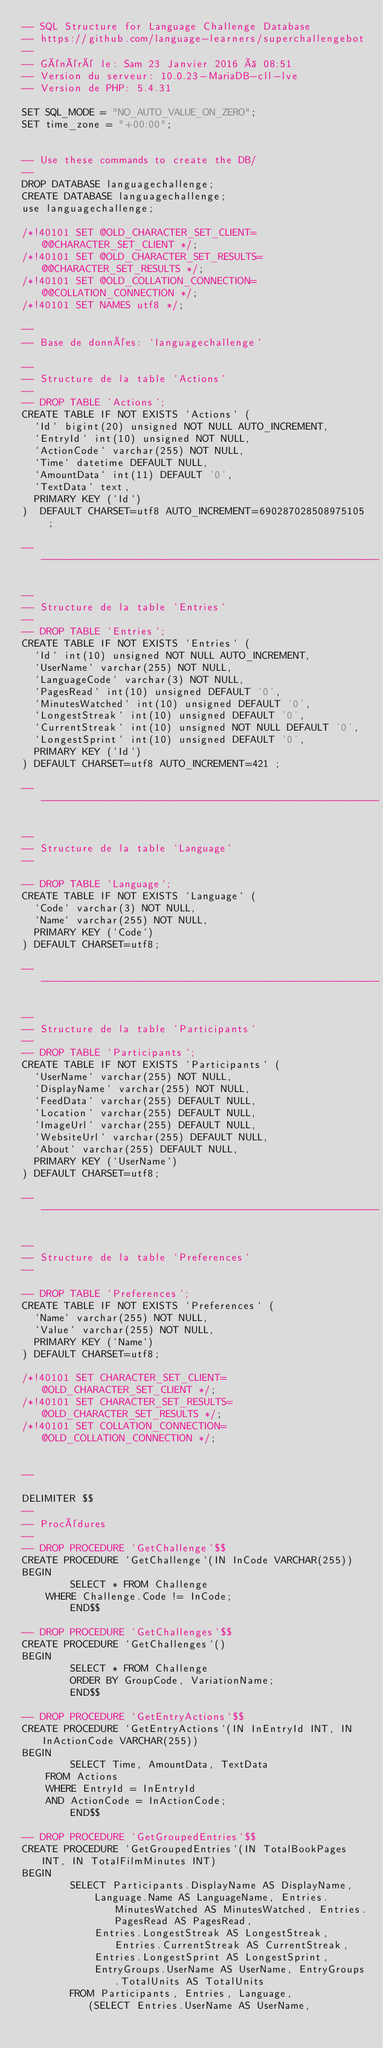Convert code to text. <code><loc_0><loc_0><loc_500><loc_500><_SQL_>-- SQL Structure for Language Challenge Database
-- https://github.com/language-learners/superchallengebot
--
-- Généré le: Sam 23 Janvier 2016 à 08:51
-- Version du serveur: 10.0.23-MariaDB-cll-lve
-- Version de PHP: 5.4.31

SET SQL_MODE = "NO_AUTO_VALUE_ON_ZERO";
SET time_zone = "+00:00";


-- Use these commands to create the DB/
-- 
DROP DATABASE languagechallenge;
CREATE DATABASE languagechallenge;
use languagechallenge;

/*!40101 SET @OLD_CHARACTER_SET_CLIENT=@@CHARACTER_SET_CLIENT */;
/*!40101 SET @OLD_CHARACTER_SET_RESULTS=@@CHARACTER_SET_RESULTS */;
/*!40101 SET @OLD_COLLATION_CONNECTION=@@COLLATION_CONNECTION */;
/*!40101 SET NAMES utf8 */;

--
-- Base de données: `languagechallenge`

--
-- Structure de la table `Actions`
--
-- DROP TABLE `Actions`;
CREATE TABLE IF NOT EXISTS `Actions` (
  `Id` bigint(20) unsigned NOT NULL AUTO_INCREMENT,
  `EntryId` int(10) unsigned NOT NULL,
  `ActionCode` varchar(255) NOT NULL,
  `Time` datetime DEFAULT NULL,
  `AmountData` int(11) DEFAULT '0',
  `TextData` text,
  PRIMARY KEY (`Id`)
)  DEFAULT CHARSET=utf8 AUTO_INCREMENT=690287028508975105 ;

-- --------------------------------------------------------

--
-- Structure de la table `Entries`
--
-- DROP TABLE `Entries`;
CREATE TABLE IF NOT EXISTS `Entries` (
  `Id` int(10) unsigned NOT NULL AUTO_INCREMENT,
  `UserName` varchar(255) NOT NULL,
  `LanguageCode` varchar(3) NOT NULL,
  `PagesRead` int(10) unsigned DEFAULT '0',
  `MinutesWatched` int(10) unsigned DEFAULT '0',
  `LongestStreak` int(10) unsigned DEFAULT '0',
  `CurrentStreak` int(10) unsigned NOT NULL DEFAULT '0',
  `LongestSprint` int(10) unsigned DEFAULT '0',
  PRIMARY KEY (`Id`)
) DEFAULT CHARSET=utf8 AUTO_INCREMENT=421 ;

-- --------------------------------------------------------

--
-- Structure de la table `Language`
--

-- DROP TABLE `Language`;
CREATE TABLE IF NOT EXISTS `Language` (
  `Code` varchar(3) NOT NULL,
  `Name` varchar(255) NOT NULL,
  PRIMARY KEY (`Code`)
) DEFAULT CHARSET=utf8;

-- --------------------------------------------------------

--
-- Structure de la table `Participants`
--
-- DROP TABLE `Participants`;
CREATE TABLE IF NOT EXISTS `Participants` (
  `UserName` varchar(255) NOT NULL,
  `DisplayName` varchar(255) NOT NULL,
  `FeedData` varchar(255) DEFAULT NULL,
  `Location` varchar(255) DEFAULT NULL,
  `ImageUrl` varchar(255) DEFAULT NULL,
  `WebsiteUrl` varchar(255) DEFAULT NULL,
  `About` varchar(255) DEFAULT NULL,
  PRIMARY KEY (`UserName`)
) DEFAULT CHARSET=utf8;

-- --------------------------------------------------------

--
-- Structure de la table `Preferences`
--

-- DROP TABLE `Preferences`;
CREATE TABLE IF NOT EXISTS `Preferences` (
  `Name` varchar(255) NOT NULL,
  `Value` varchar(255) NOT NULL,
  PRIMARY KEY (`Name`)
) DEFAULT CHARSET=utf8;

/*!40101 SET CHARACTER_SET_CLIENT=@OLD_CHARACTER_SET_CLIENT */;
/*!40101 SET CHARACTER_SET_RESULTS=@OLD_CHARACTER_SET_RESULTS */;
/*!40101 SET COLLATION_CONNECTION=@OLD_COLLATION_CONNECTION */;


--

DELIMITER $$
--
-- Procédures
--
-- DROP PROCEDURE `GetChallenge`$$
CREATE PROCEDURE `GetChallenge`(IN InCode VARCHAR(255))
BEGIN
        SELECT * FROM Challenge
    WHERE Challenge.Code != InCode;
        END$$

-- DROP PROCEDURE `GetChallenges`$$
CREATE PROCEDURE `GetChallenges`()
BEGIN
        SELECT * FROM Challenge 
        ORDER BY GroupCode, VariationName;
        END$$

-- DROP PROCEDURE `GetEntryActions`$$
CREATE PROCEDURE `GetEntryActions`(IN InEntryId INT, IN InActionCode VARCHAR(255))
BEGIN
        SELECT Time, AmountData, TextData
    FROM Actions
    WHERE EntryId = InEntryId
    AND ActionCode = InActionCode;
        END$$

-- DROP PROCEDURE `GetGroupedEntries`$$
CREATE PROCEDURE `GetGroupedEntries`(IN TotalBookPages INT, IN TotalFilmMinutes INT)
BEGIN
        SELECT Participants.DisplayName AS DisplayName, 
            Language.Name AS LanguageName, Entries.MinutesWatched AS MinutesWatched, Entries.PagesRead AS PagesRead,
            Entries.LongestStreak AS LongestStreak, Entries.CurrentStreak AS CurrentStreak,
            Entries.LongestSprint AS LongestSprint,
            EntryGroups.UserName AS UserName, EntryGroups.TotalUnits AS TotalUnits
        FROM Participants, Entries, Language, 
           (SELECT Entries.UserName AS UserName,</code> 